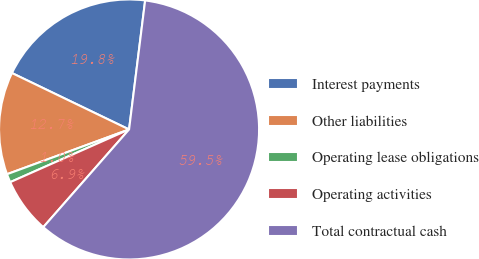Convert chart to OTSL. <chart><loc_0><loc_0><loc_500><loc_500><pie_chart><fcel>Interest payments<fcel>Other liabilities<fcel>Operating lease obligations<fcel>Operating activities<fcel>Total contractual cash<nl><fcel>19.83%<fcel>12.74%<fcel>1.05%<fcel>6.89%<fcel>59.5%<nl></chart> 